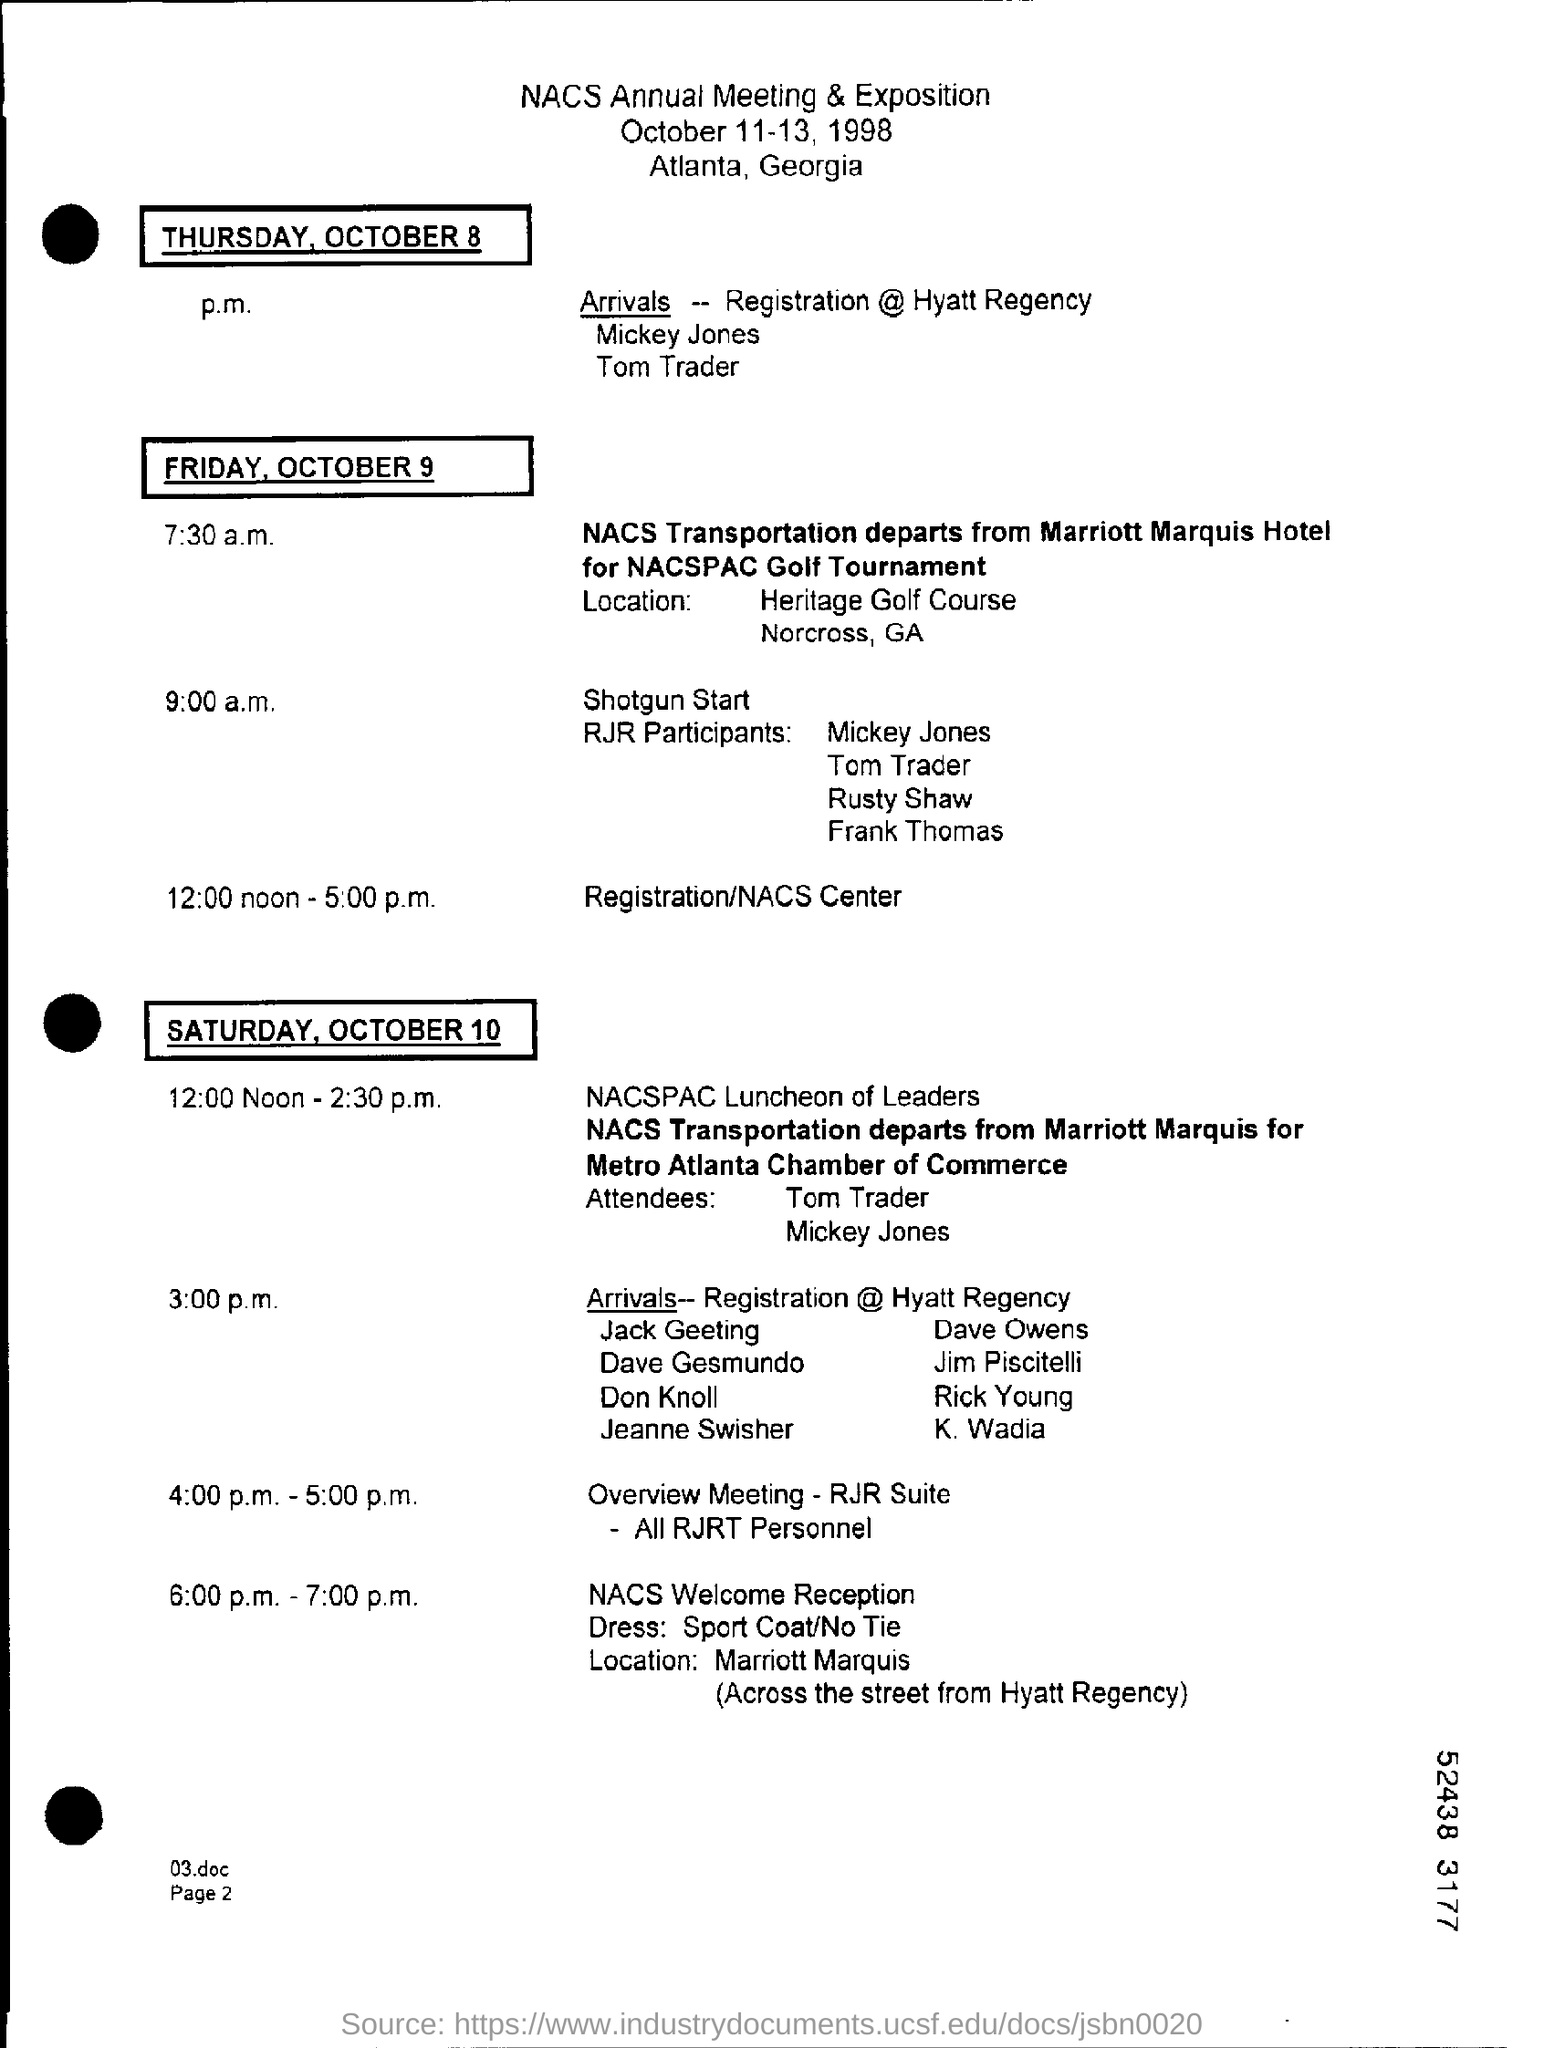When is the NACS Annual Meeting & Exposition held?
Offer a terse response. October 11-13, 1998. What time is the overview meeting of all RJRT personnel scheduled?
Offer a terse response. 4:00 p.m.-5:00 p.m. 